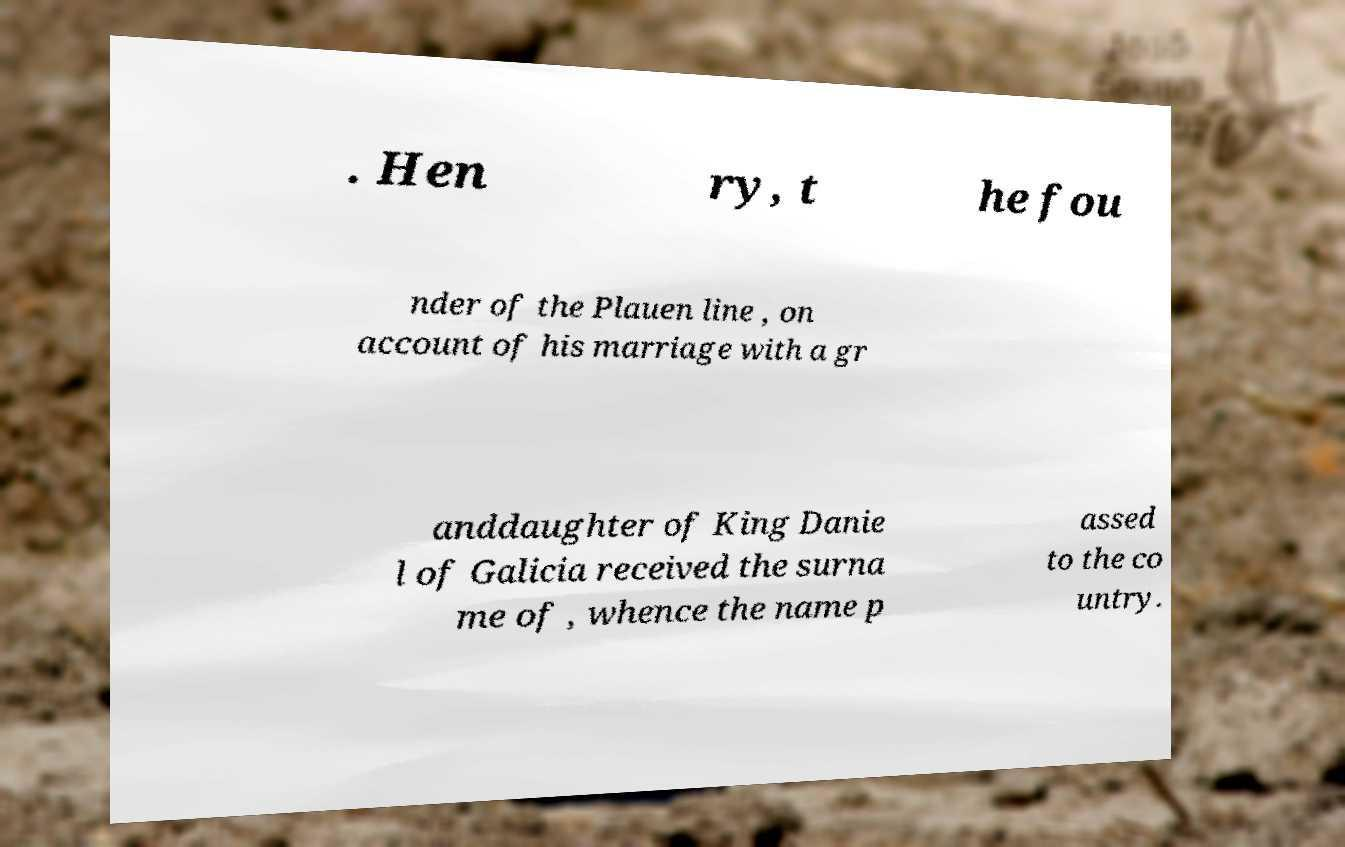Could you assist in decoding the text presented in this image and type it out clearly? . Hen ry, t he fou nder of the Plauen line , on account of his marriage with a gr anddaughter of King Danie l of Galicia received the surna me of , whence the name p assed to the co untry. 